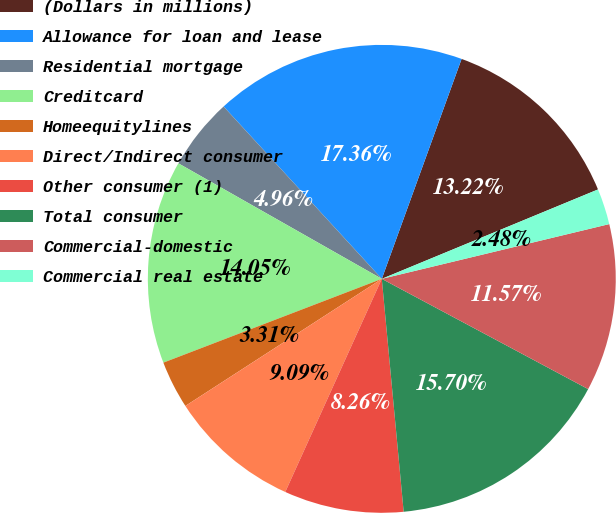Convert chart. <chart><loc_0><loc_0><loc_500><loc_500><pie_chart><fcel>(Dollars in millions)<fcel>Allowance for loan and lease<fcel>Residential mortgage<fcel>Creditcard<fcel>Homeequitylines<fcel>Direct/Indirect consumer<fcel>Other consumer (1)<fcel>Total consumer<fcel>Commercial-domestic<fcel>Commercial real estate<nl><fcel>13.22%<fcel>17.36%<fcel>4.96%<fcel>14.05%<fcel>3.31%<fcel>9.09%<fcel>8.26%<fcel>15.7%<fcel>11.57%<fcel>2.48%<nl></chart> 